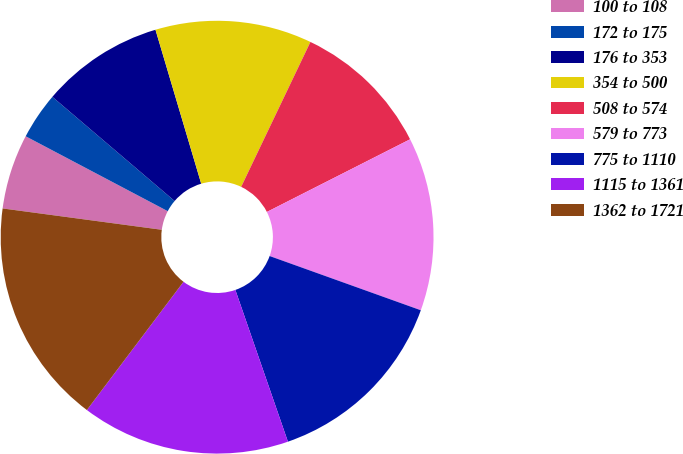Convert chart. <chart><loc_0><loc_0><loc_500><loc_500><pie_chart><fcel>100 to 108<fcel>172 to 175<fcel>176 to 353<fcel>354 to 500<fcel>508 to 574<fcel>579 to 773<fcel>775 to 1110<fcel>1115 to 1361<fcel>1362 to 1721<nl><fcel>5.6%<fcel>3.51%<fcel>9.17%<fcel>11.69%<fcel>10.43%<fcel>12.95%<fcel>14.21%<fcel>15.58%<fcel>16.84%<nl></chart> 